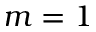<formula> <loc_0><loc_0><loc_500><loc_500>m = 1</formula> 